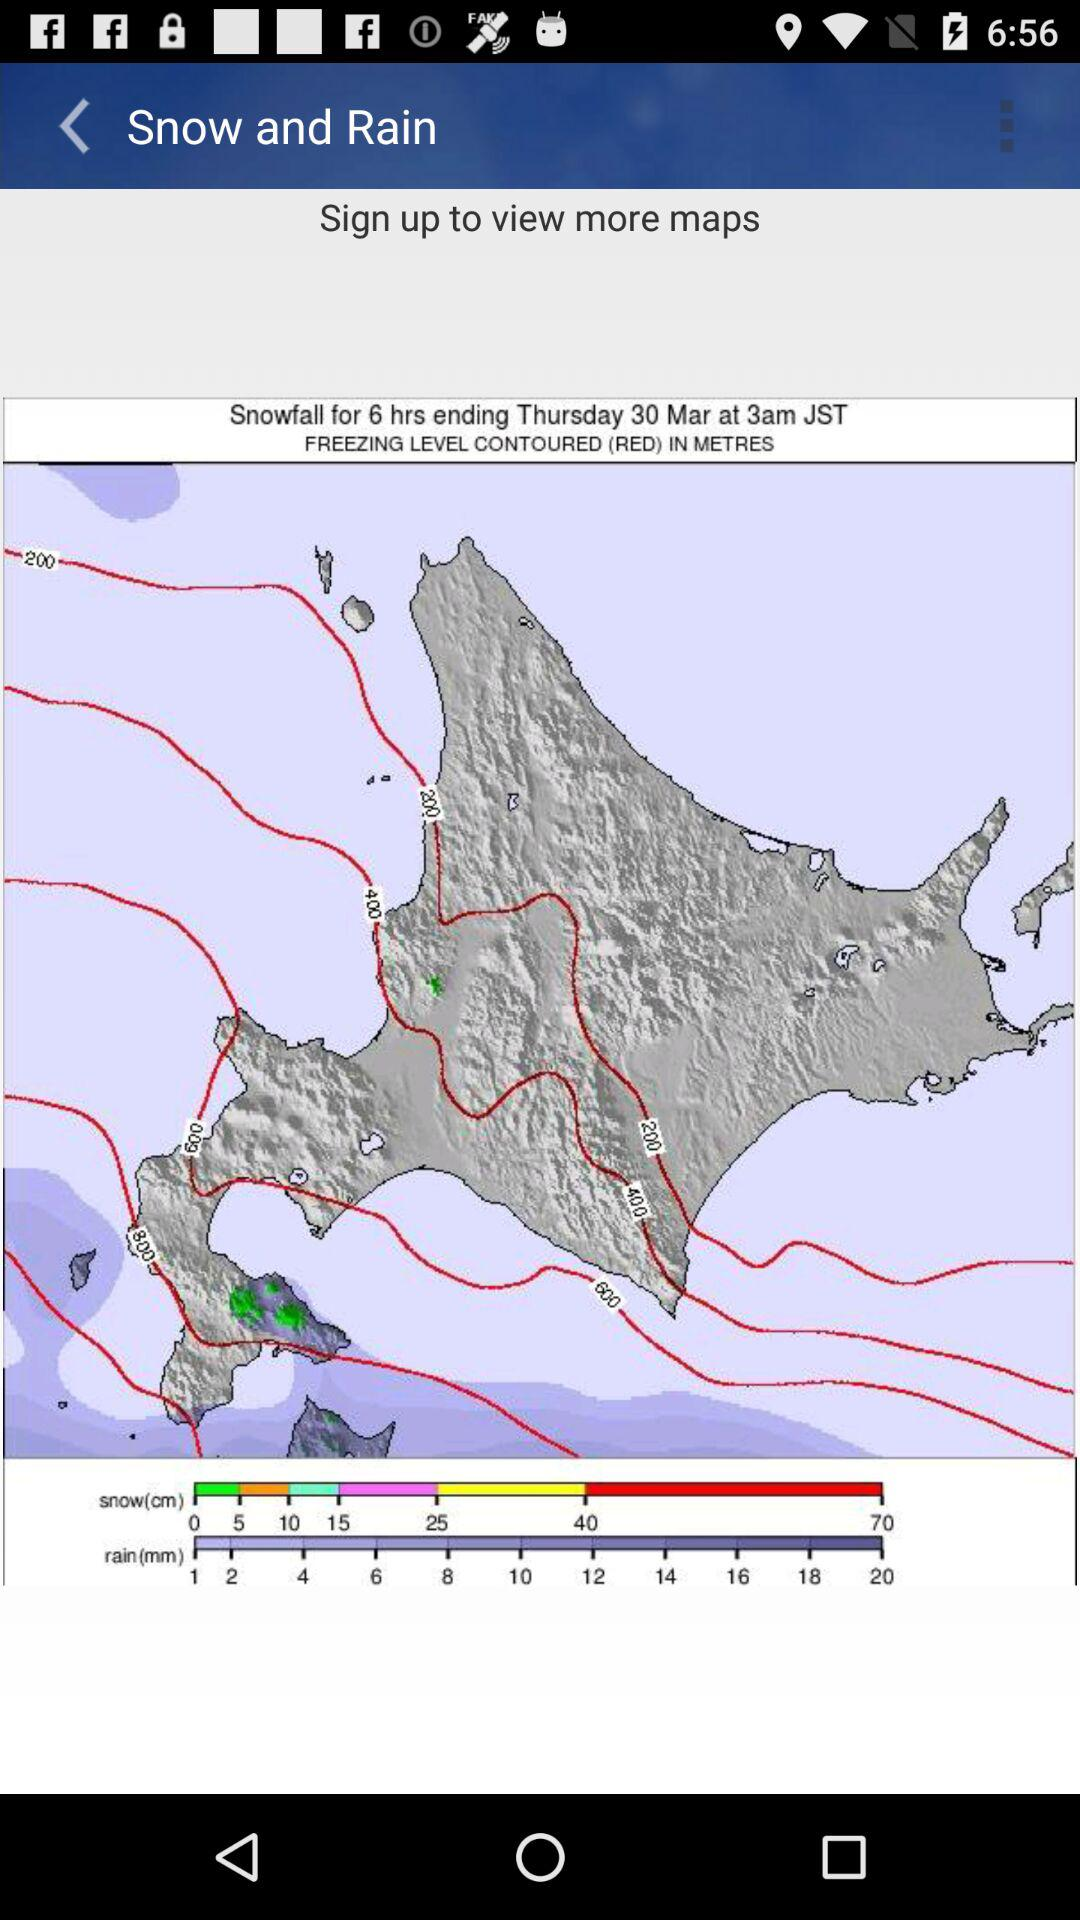At what time will the snowfall end on Thursday, March 30? The snowfall will end at 3 AM. 